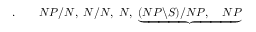Convert formula to latex. <formula><loc_0><loc_0><loc_500><loc_500>. \quad N P / N , \, N / N , \, N , \, \underbrace { ( N P \ S ) / N P , \quad N P }</formula> 